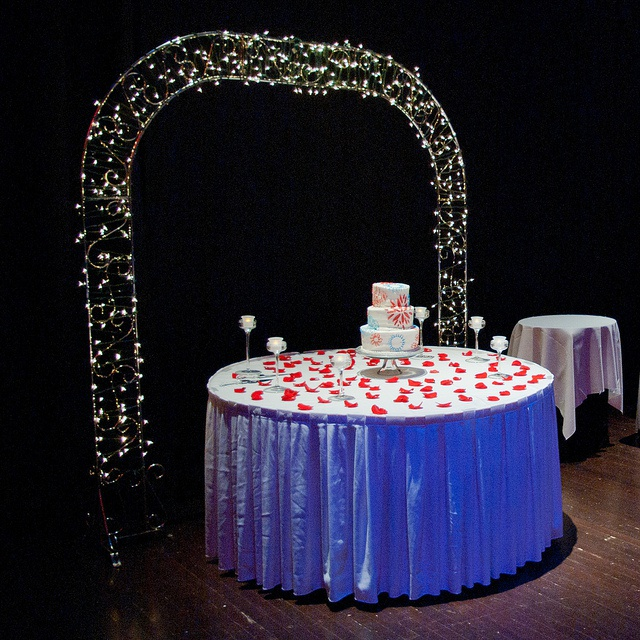Describe the objects in this image and their specific colors. I can see dining table in black, darkblue, lightgray, blue, and navy tones, dining table in black, gray, darkgray, and purple tones, cake in black, lightgray, darkgray, and tan tones, wine glass in black, darkgray, and lightgray tones, and wine glass in black, lightgray, darkgray, and pink tones in this image. 